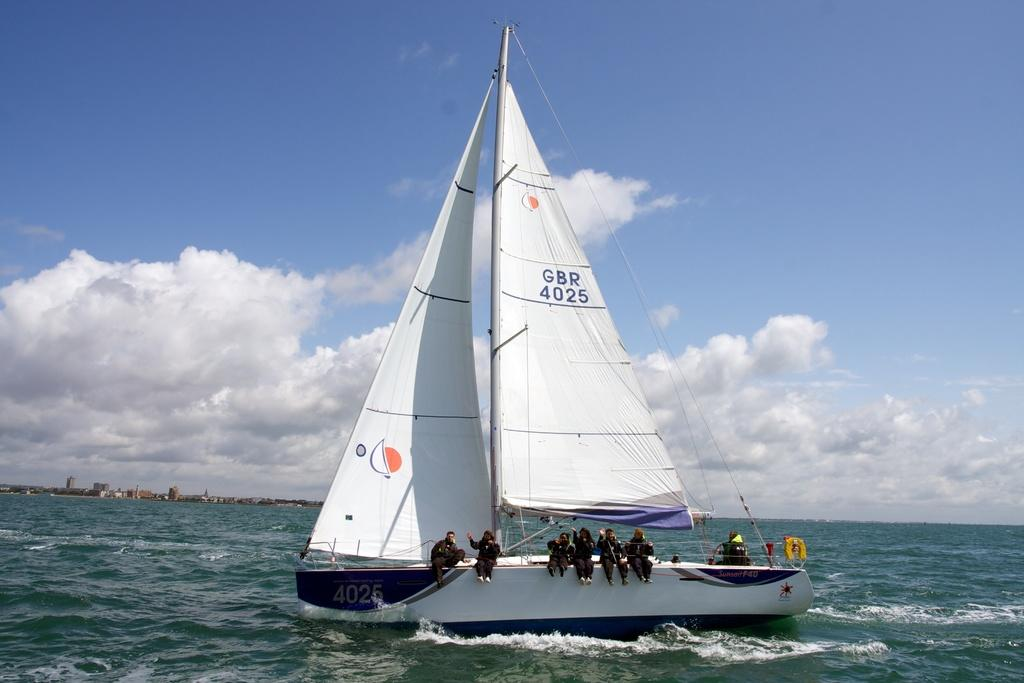What type of vehicle is in the image? There is a sailboat in the image. Who is on the sailboat? People are sitting on the sailboat. What is the sailboat doing in the image? The sailboat is floating on the water. What can be seen in the background of the image? There is a blue sky with clouds visible in the background of the image. What type of verse is being recited by the people on the sailboat? There is no indication in the image that people are reciting a verse, so it cannot be determined from the picture. 